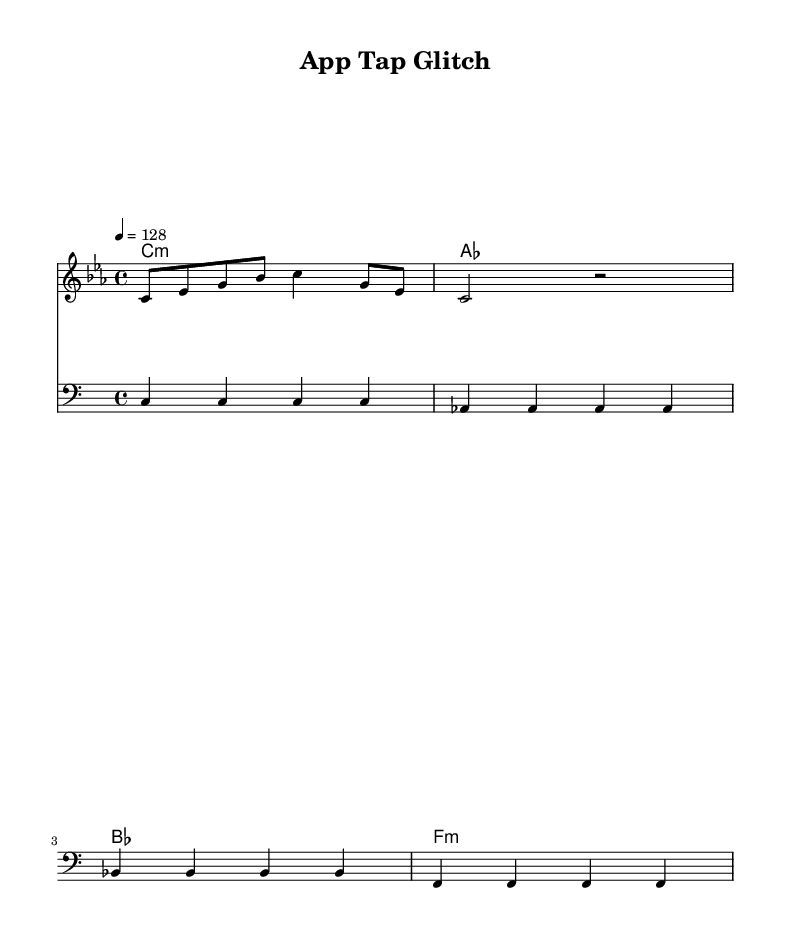What is the key signature of this music? The key signature is C minor, which has three flats (B flat, E flat, and A flat). This is identified from the \key c \minor command in the global music settings.
Answer: C minor What is the time signature of this piece? The time signature is 4/4, indicated by the \time 4/4 command in the global music settings. This means there are four beats per measure and the quarter note gets one beat.
Answer: 4/4 What is the tempo of the piece? The tempo is set at 128 beats per minute, as denoted by the \tempo 4 = 128 command. This indicates the speed of the piece, measured in beats per minute.
Answer: 128 What is the duration of the first chord in the harmony? The first chord is a C minor chord played for a whole note duration, which is indicated by c1:m in the chord mode section of the code. A whole note typically lasts four beats in 4/4 time.
Answer: Whole note How many measures are in the melody section as shown? The melody section currently shows 2 measures, as seen by the count of the bar lines that separate the notes. Each measure begins and ends with a bar line, which can be observed in the provided melody code.
Answer: 2 measures What is the lowest note in the bass part? The lowest note in the bass part is C, which is the first note listed in the bass section of the music. It is indicated as c4, representing the note C in the bass clef.
Answer: C What overall effect might the combination of sounds in this piece suggest, given its experimental nature? The experimental nature suggests an abstract and unconventional sound landscape, where glitch-hop influences might incorporate stuttering rhythms and layered textures, inspired by the irregularities in mobile app user interfaces.
Answer: Abstract sound landscape 